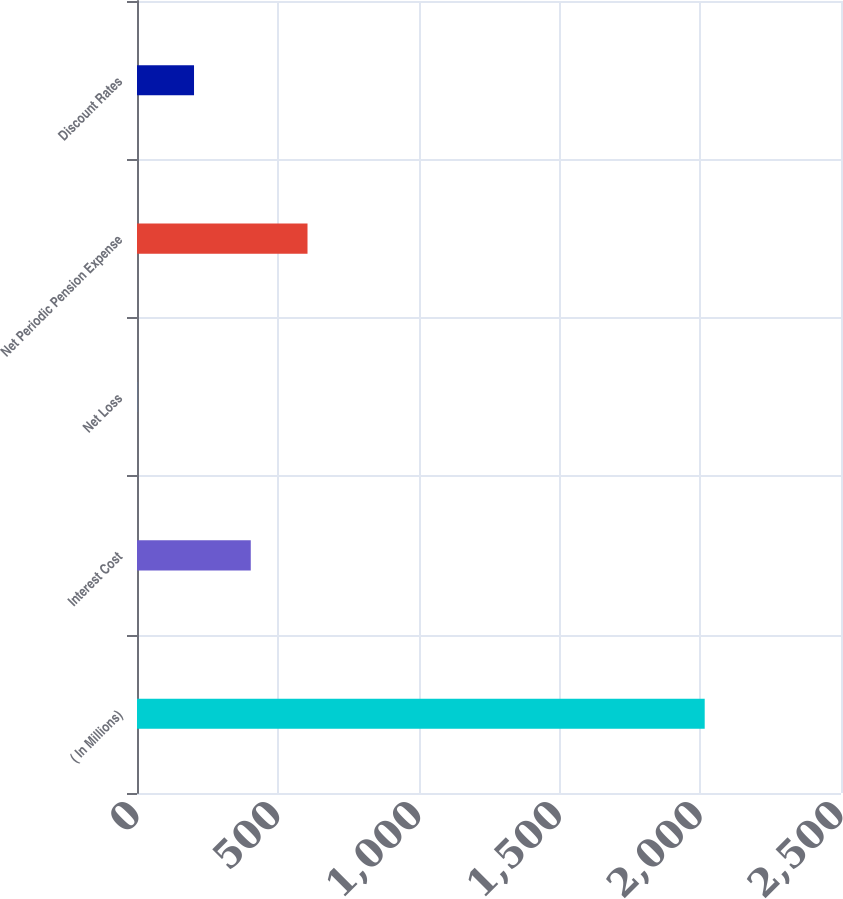<chart> <loc_0><loc_0><loc_500><loc_500><bar_chart><fcel>( In Millions)<fcel>Interest Cost<fcel>Net Loss<fcel>Net Periodic Pension Expense<fcel>Discount Rates<nl><fcel>2016<fcel>404<fcel>1<fcel>605.5<fcel>202.5<nl></chart> 